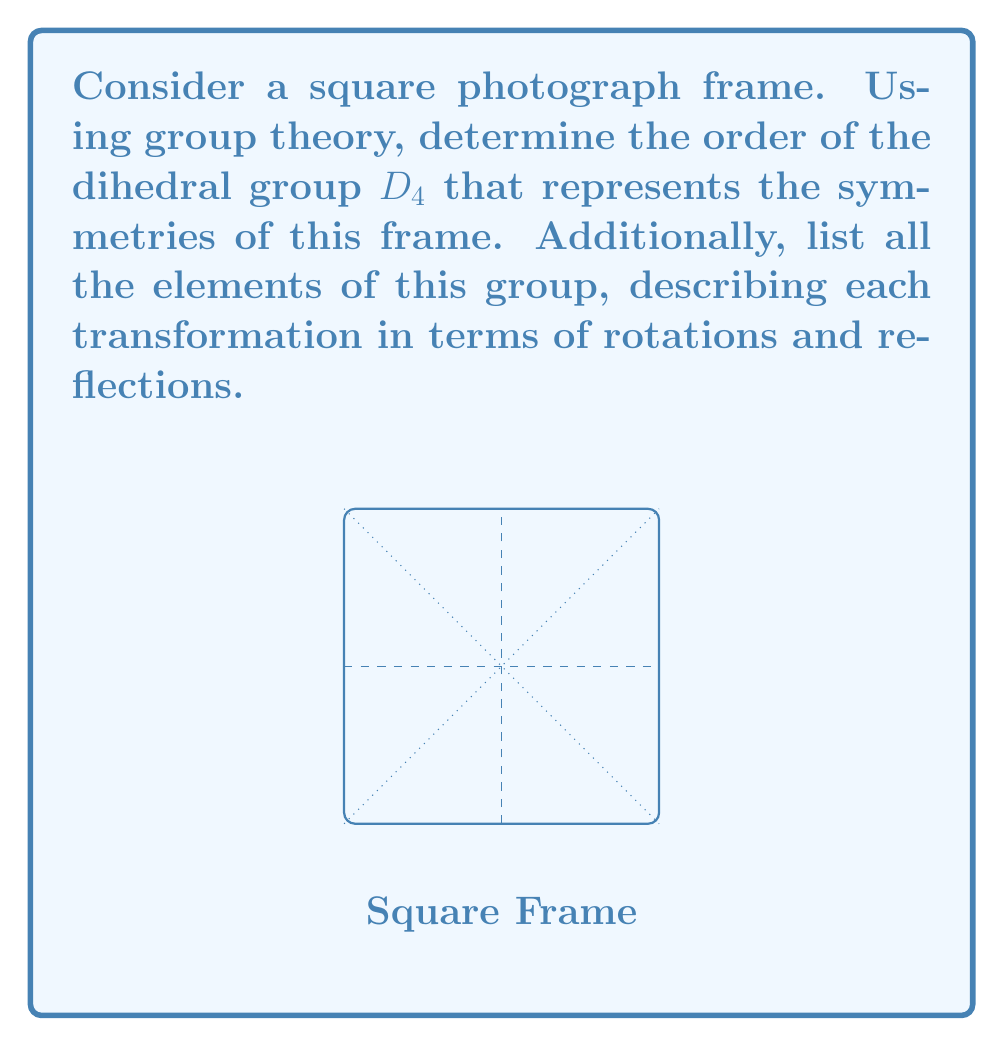Solve this math problem. To solve this problem, let's break it down step-by-step:

1) The dihedral group $D_4$ represents the symmetries of a square. These symmetries include rotations and reflections that preserve the shape of the square.

2) To find the order of $D_4$, we need to count all possible symmetry operations:

   a) Rotations: There are 4 rotations (including the identity rotation):
      - 0° (identity)
      - 90° clockwise
      - 180°
      - 270° clockwise (or 90° counterclockwise)

   b) Reflections: There are 4 reflections:
      - Vertical axis
      - Horizontal axis
      - Diagonal (top-left to bottom-right)
      - Diagonal (top-right to bottom-left)

3) The total number of symmetry operations is 4 + 4 = 8. Therefore, the order of $D_4$ is 8.

4) Now, let's list all elements of $D_4$ using the following notation:
   - $e$: identity
   - $r$: 90° clockwise rotation
   - $r^2$: 180° rotation
   - $r^3$: 270° clockwise rotation
   - $f_v$: reflection across vertical axis
   - $f_h$: reflection across horizontal axis
   - $f_d$: reflection across diagonal (top-left to bottom-right)
   - $f_d'$: reflection across diagonal (top-right to bottom-left)

5) The complete list of elements in $D_4$ is:
   $\{e, r, r^2, r^3, f_v, f_h, f_d, f_d'\}$

This group structure captures all possible ways to transform the square photograph frame while maintaining its shape and orientation within the frame.
Answer: Order of $D_4$: 8
Elements: $\{e, r, r^2, r^3, f_v, f_h, f_d, f_d'\}$ 